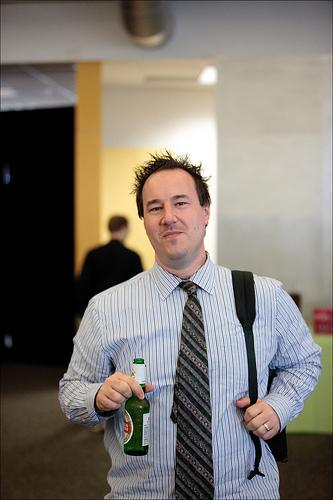Question: how many people are int his picture?
Choices:
A. Three.
B. Four.
C. One.
D. Two.
Answer with the letter. Answer: D Question: what type of hair does the man have?
Choices:
A. Flat.
B. Spiky.
C. Thin.
D. Curly.
Answer with the letter. Answer: B 